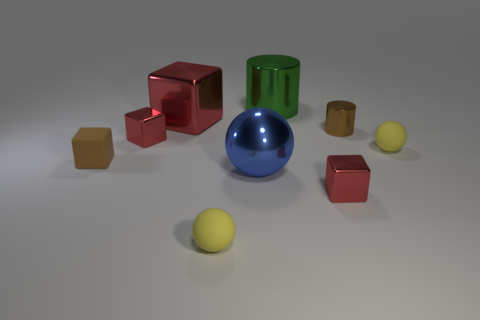Does the blue sphere have the same size as the yellow ball that is to the right of the tiny cylinder?
Provide a short and direct response. No. Is the number of small red metallic objects that are left of the big blue thing less than the number of big yellow metallic spheres?
Make the answer very short. No. How many tiny cubes are the same color as the big metallic cube?
Your answer should be compact. 2. Are there fewer metal cylinders than large red rubber cylinders?
Provide a short and direct response. No. Do the green thing and the big blue sphere have the same material?
Provide a succinct answer. Yes. What number of other objects are the same size as the matte cube?
Provide a short and direct response. 5. The rubber thing on the right side of the cube that is in front of the tiny matte block is what color?
Keep it short and to the point. Yellow. What number of other things are there of the same shape as the brown metal object?
Provide a short and direct response. 1. Is there a tiny yellow object that has the same material as the big red block?
Ensure brevity in your answer.  No. There is a brown cylinder that is the same size as the brown block; what is it made of?
Keep it short and to the point. Metal. 